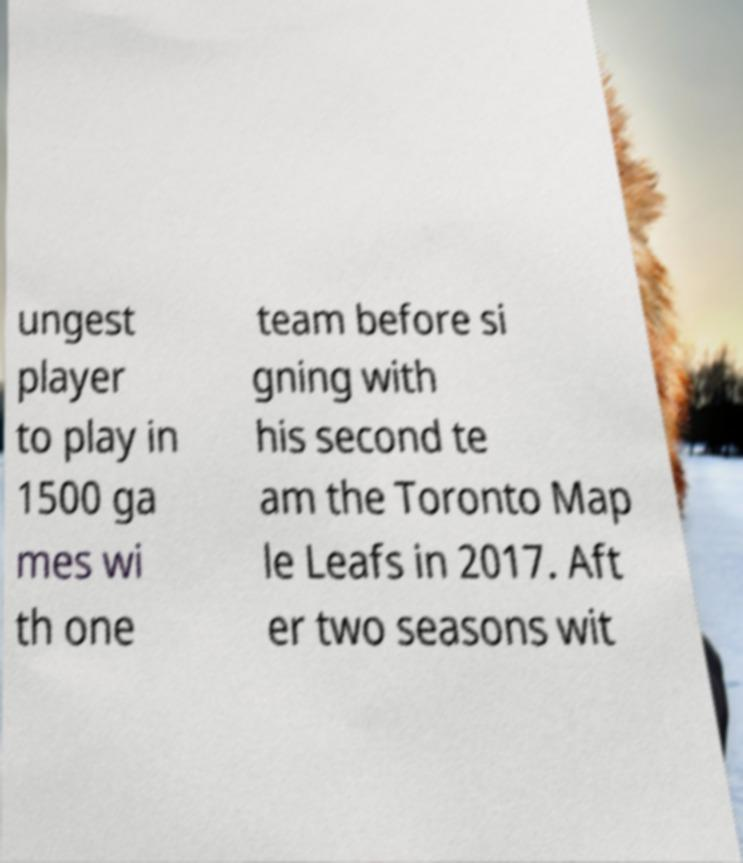Can you read and provide the text displayed in the image?This photo seems to have some interesting text. Can you extract and type it out for me? ungest player to play in 1500 ga mes wi th one team before si gning with his second te am the Toronto Map le Leafs in 2017. Aft er two seasons wit 